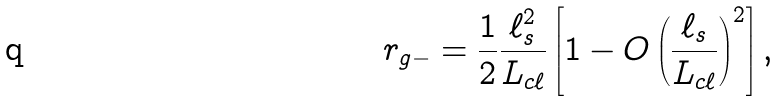<formula> <loc_0><loc_0><loc_500><loc_500>r _ { g - } = \frac { 1 } { 2 } \frac { \ell _ { s } ^ { 2 } } { L _ { c \ell } } \left [ 1 - O \left ( \frac { \ell _ { s } } { L _ { c \ell } } \right ) ^ { 2 } \right ] ,</formula> 